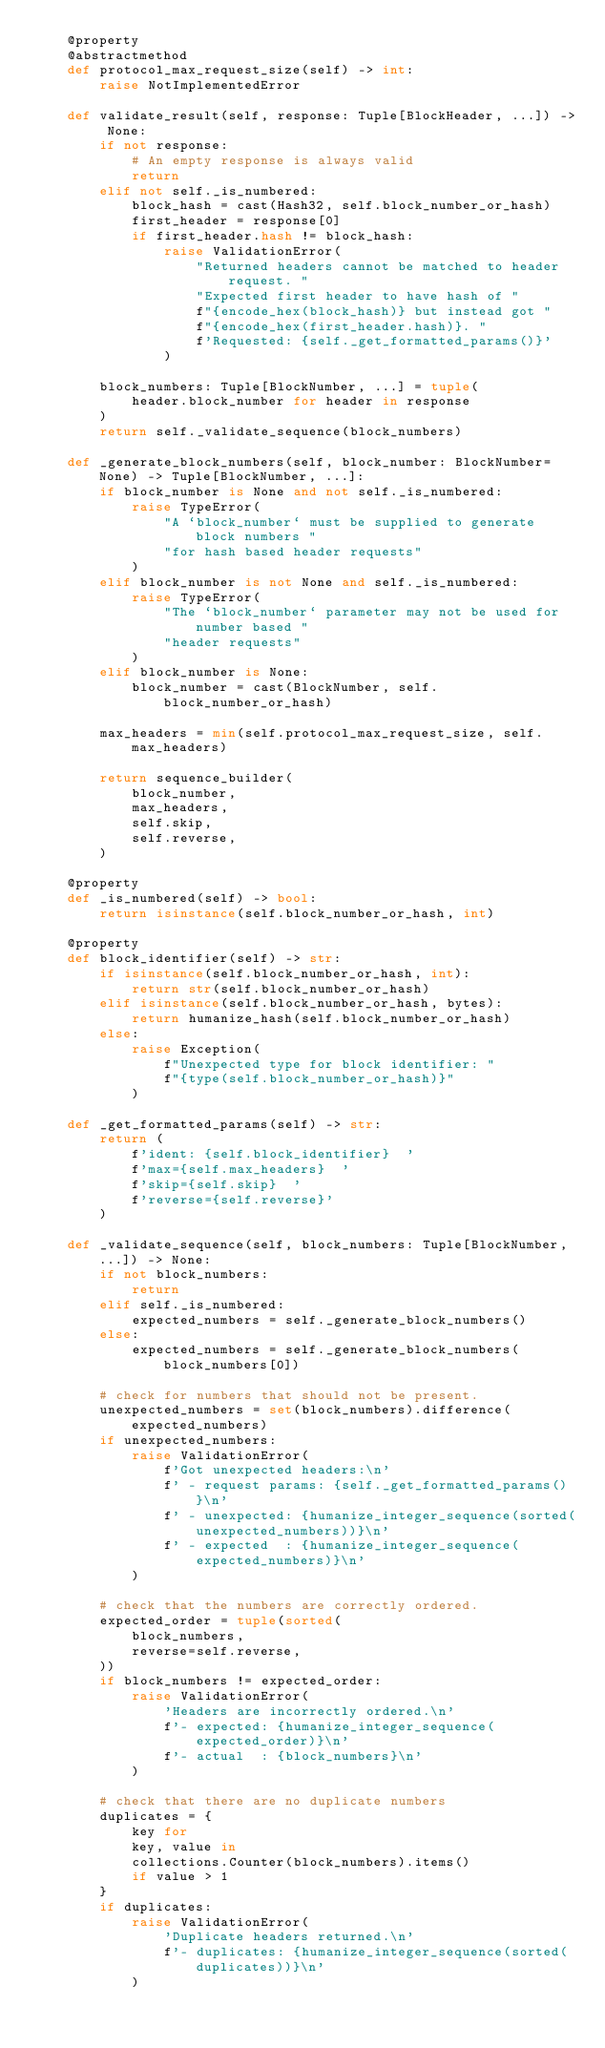<code> <loc_0><loc_0><loc_500><loc_500><_Python_>    @property
    @abstractmethod
    def protocol_max_request_size(self) -> int:
        raise NotImplementedError

    def validate_result(self, response: Tuple[BlockHeader, ...]) -> None:
        if not response:
            # An empty response is always valid
            return
        elif not self._is_numbered:
            block_hash = cast(Hash32, self.block_number_or_hash)
            first_header = response[0]
            if first_header.hash != block_hash:
                raise ValidationError(
                    "Returned headers cannot be matched to header request. "
                    "Expected first header to have hash of "
                    f"{encode_hex(block_hash)} but instead got "
                    f"{encode_hex(first_header.hash)}. "
                    f'Requested: {self._get_formatted_params()}'
                )

        block_numbers: Tuple[BlockNumber, ...] = tuple(
            header.block_number for header in response
        )
        return self._validate_sequence(block_numbers)

    def _generate_block_numbers(self, block_number: BlockNumber=None) -> Tuple[BlockNumber, ...]:
        if block_number is None and not self._is_numbered:
            raise TypeError(
                "A `block_number` must be supplied to generate block numbers "
                "for hash based header requests"
            )
        elif block_number is not None and self._is_numbered:
            raise TypeError(
                "The `block_number` parameter may not be used for number based "
                "header requests"
            )
        elif block_number is None:
            block_number = cast(BlockNumber, self.block_number_or_hash)

        max_headers = min(self.protocol_max_request_size, self.max_headers)

        return sequence_builder(
            block_number,
            max_headers,
            self.skip,
            self.reverse,
        )

    @property
    def _is_numbered(self) -> bool:
        return isinstance(self.block_number_or_hash, int)

    @property
    def block_identifier(self) -> str:
        if isinstance(self.block_number_or_hash, int):
            return str(self.block_number_or_hash)
        elif isinstance(self.block_number_or_hash, bytes):
            return humanize_hash(self.block_number_or_hash)
        else:
            raise Exception(
                f"Unexpected type for block identifier: "
                f"{type(self.block_number_or_hash)}"
            )

    def _get_formatted_params(self) -> str:
        return (
            f'ident: {self.block_identifier}  '
            f'max={self.max_headers}  '
            f'skip={self.skip}  '
            f'reverse={self.reverse}'
        )

    def _validate_sequence(self, block_numbers: Tuple[BlockNumber, ...]) -> None:
        if not block_numbers:
            return
        elif self._is_numbered:
            expected_numbers = self._generate_block_numbers()
        else:
            expected_numbers = self._generate_block_numbers(block_numbers[0])

        # check for numbers that should not be present.
        unexpected_numbers = set(block_numbers).difference(expected_numbers)
        if unexpected_numbers:
            raise ValidationError(
                f'Got unexpected headers:\n'
                f' - request params: {self._get_formatted_params()}\n'
                f' - unexpected: {humanize_integer_sequence(sorted(unexpected_numbers))}\n'
                f' - expected  : {humanize_integer_sequence(expected_numbers)}\n'
            )

        # check that the numbers are correctly ordered.
        expected_order = tuple(sorted(
            block_numbers,
            reverse=self.reverse,
        ))
        if block_numbers != expected_order:
            raise ValidationError(
                'Headers are incorrectly ordered.\n'
                f'- expected: {humanize_integer_sequence(expected_order)}\n'
                f'- actual  : {block_numbers}\n'
            )

        # check that there are no duplicate numbers
        duplicates = {
            key for
            key, value in
            collections.Counter(block_numbers).items()
            if value > 1
        }
        if duplicates:
            raise ValidationError(
                'Duplicate headers returned.\n'
                f'- duplicates: {humanize_integer_sequence(sorted(duplicates))}\n'
            )
</code> 